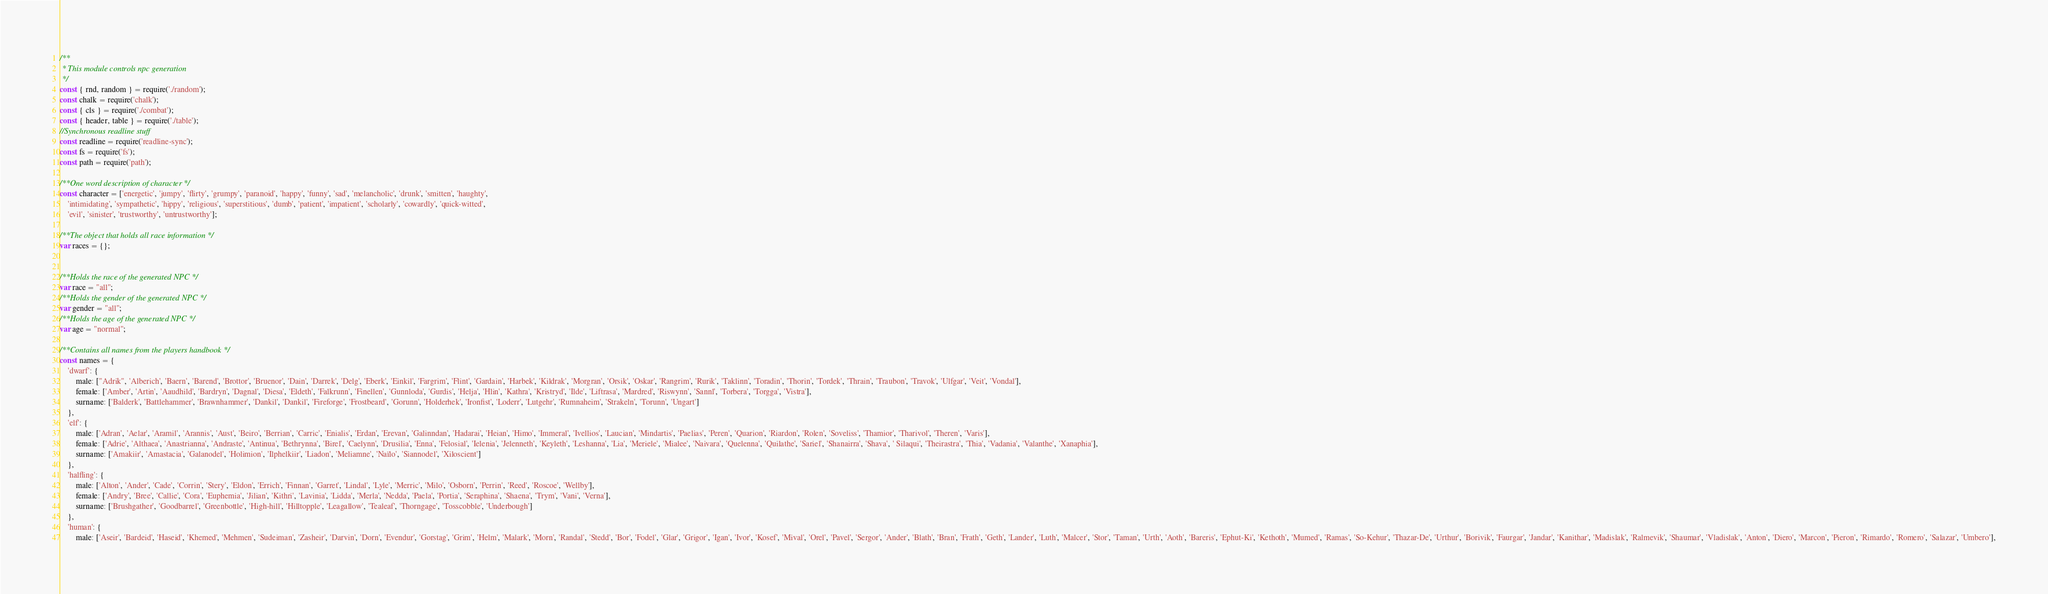<code> <loc_0><loc_0><loc_500><loc_500><_JavaScript_>/**
 * This module controls npc generation
 */
const { rnd, random } = require('./random');
const chalk = require('chalk');
const { cls } = require('./combat');
const { header, table } = require('./table');
//Synchronous readline stuff
const readline = require('readline-sync');
const fs = require('fs');
const path = require('path');

/**One word description of character */
const character = ['energetic', 'jumpy', 'flirty', 'grumpy', 'paranoid', 'happy', 'funny', 'sad', 'melancholic', 'drunk', 'smitten', 'haughty',
    'intimidating', 'sympathetic', 'hippy', 'religious', 'superstitious', 'dumb', 'patient', 'impatient', 'scholarly', 'cowardly', 'quick-witted',
    'evil', 'sinister', 'trustworthy', 'untrustworthy'];

/**The object that holds all race information */
var races = {};


/**Holds the race of the generated NPC */
var race = "all";
/**Holds the gender of the generated NPC */
var gender = "all";
/**Holds the age of the generated NPC */
var age = "normal";

/**Contains all names from the players handbook */
const names = {
    'dwarf': {
        male: ["Adrik", 'Alberich', 'Baern', 'Barend', 'Brottor', 'Bruenor', 'Dain', 'Darrek', 'Delg', 'Eberk', 'Einkil', 'Fargrim', 'Flint', 'Gardain', 'Harbek', 'Kildrak', 'Morgran', 'Orsik', 'Oskar', 'Rangrim', 'Rurik', 'Taklinn', 'Toradin', 'Thorin', 'Tordek', 'Thrain', 'Traubon', 'Travok', 'Ulfgar', 'Veit', 'Vondal'],
        female: ['Amber', 'Artin', 'Aaudhild', 'Bardryn', 'Dagnal', 'Diesa', 'Eldeth', 'Falkrunn', 'Finellen', 'Gunnloda', 'Gurdis', 'Helja', 'Hlin', 'Kathra', 'Kristryd', 'Ilde', 'Liftrasa', 'Mardred', 'Riswynn', 'Sannl', 'Torbera', 'Torgga', 'Vistra'],
        surname: ['Balderk', 'Battlehammer', 'Brawnhammer', 'Dankil', 'Dankil', 'Fireforge', 'Frostbeard', 'Gorunn', 'Holderhek', 'Ironfist', 'Loderr', 'Lutgehr', 'Rumnaheim', 'Strakeln', 'Torunn', 'Ungart']
    },
    'elf': {
        male: ['Adran', 'Aelar', 'Aramil', 'Arannis', 'Aust', 'Beiro', 'Berrian', 'Carric', 'Enialis', 'Erdan', 'Erevan', 'Galinndan', 'Hadarai', 'Heian', 'Himo', 'Immeral', 'Ivellios', 'Laucian', 'Mindartis', 'Paelias', 'Peren', 'Quarion', 'Riardon', 'Rolen', 'Soveliss', 'Thamior', 'Tharivol', 'Theren', 'Varis'],
        female: ['Adrie', 'Althaea', 'Anastrianna', 'Andraste', 'Antinua', 'Bethrynna', 'Birel', 'Caelynn', 'Drusilia', 'Enna', 'Felosial', 'Ielenia', 'Jelenneth', 'Keyleth', 'Leshanna', 'Lia', 'Meriele', 'Mialee', 'Naivara', 'Quelenna', 'Quilathe', 'Sariel', 'Shanairra', 'Shava', ' Silaqui', 'Theirastra', 'Thia', 'Vadania', 'Valanthe', 'Xanaphia'],
        surname: ['Amakiir', 'Amastacia', 'Galanodel', 'Holimion', 'Ilphelkiir', 'Liadon', 'Meliamne', 'Naïlo', 'Siannodel', 'Xiloscient']
    },
    'halfling': {
        male: ['Alton', 'Ander', 'Cade', 'Corrin', 'Stery', 'Eldon', 'Errich', 'Finnan', 'Garret', 'Lindal', 'Lyle', 'Merric', 'Milo', 'Osborn', 'Perrin', 'Reed', 'Roscoe', 'Wellby'],
        female: ['Andry', 'Bree', 'Callie', 'Cora', 'Euphemia', 'Jilian', 'Kithri', 'Lavinia', 'Lidda', 'Merla', 'Nedda', 'Paela', 'Portia', 'Seraphina', 'Shaena', 'Trym', 'Vani', 'Verna'],
        surname: ['Brushgather', 'Goodbarrel', 'Greenbottle', 'High-hill', 'Hilltopple', 'Leagallow', 'Tealeaf', 'Thorngage', 'Tosscobble', 'Underbough']
    },
    'human': {
        male: ['Aseir', 'Bardeid', 'Haseid', 'Khemed', 'Mehmen', 'Sudeiman', 'Zasheir', 'Darvin', 'Dorn', 'Evendur', 'Gorstag', 'Grim', 'Helm', 'Malark', 'Morn', 'Randal', 'Stedd', 'Bor', 'Fodel', 'Glar', 'Grigor', 'Igan', 'Ivor', 'Kosef', 'Mival', 'Orel', 'Pavel', 'Sergor', 'Ander', 'Blath', 'Bran', 'Frath', 'Geth', 'Lander', 'Luth', 'Malcer', 'Stor', 'Taman', 'Urth', 'Aoth', 'Bareris', 'Ephut-Ki', 'Kethoth', 'Mumed', 'Ramas', 'So-Kehur', 'Thazar-De', 'Urthur', 'Borivik', 'Faurgar', 'Jandar', 'Kanithar', 'Madislak', 'Ralmevik', 'Shaumar', 'Vladislak', 'Anton', 'Diero', 'Marcon', 'Pieron', 'Rimardo', 'Romero', 'Salazar', 'Umbero'],</code> 